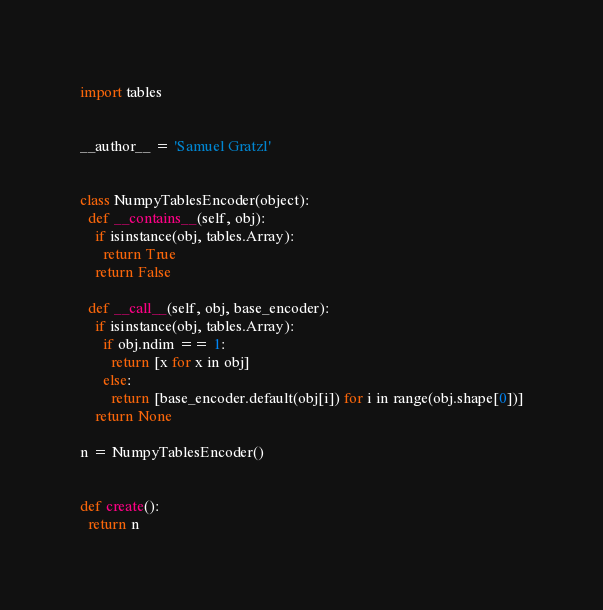Convert code to text. <code><loc_0><loc_0><loc_500><loc_500><_Python_>import tables


__author__ = 'Samuel Gratzl'


class NumpyTablesEncoder(object):
  def __contains__(self, obj):
    if isinstance(obj, tables.Array):
      return True
    return False

  def __call__(self, obj, base_encoder):
    if isinstance(obj, tables.Array):
      if obj.ndim == 1:
        return [x for x in obj]
      else:
        return [base_encoder.default(obj[i]) for i in range(obj.shape[0])]
    return None

n = NumpyTablesEncoder()


def create():
  return n
</code> 